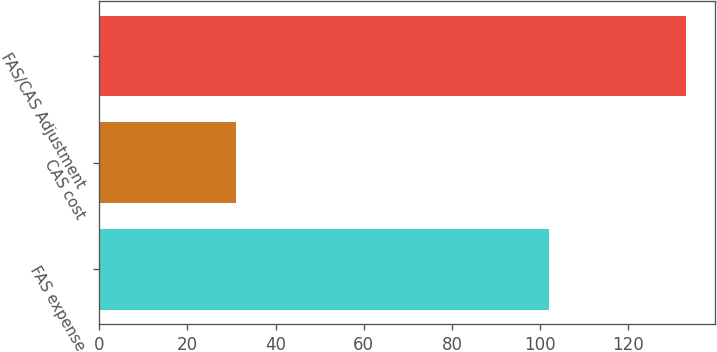<chart> <loc_0><loc_0><loc_500><loc_500><bar_chart><fcel>FAS expense<fcel>CAS cost<fcel>FAS/CAS Adjustment<nl><fcel>102<fcel>31<fcel>133<nl></chart> 